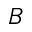Convert formula to latex. <formula><loc_0><loc_0><loc_500><loc_500>B</formula> 